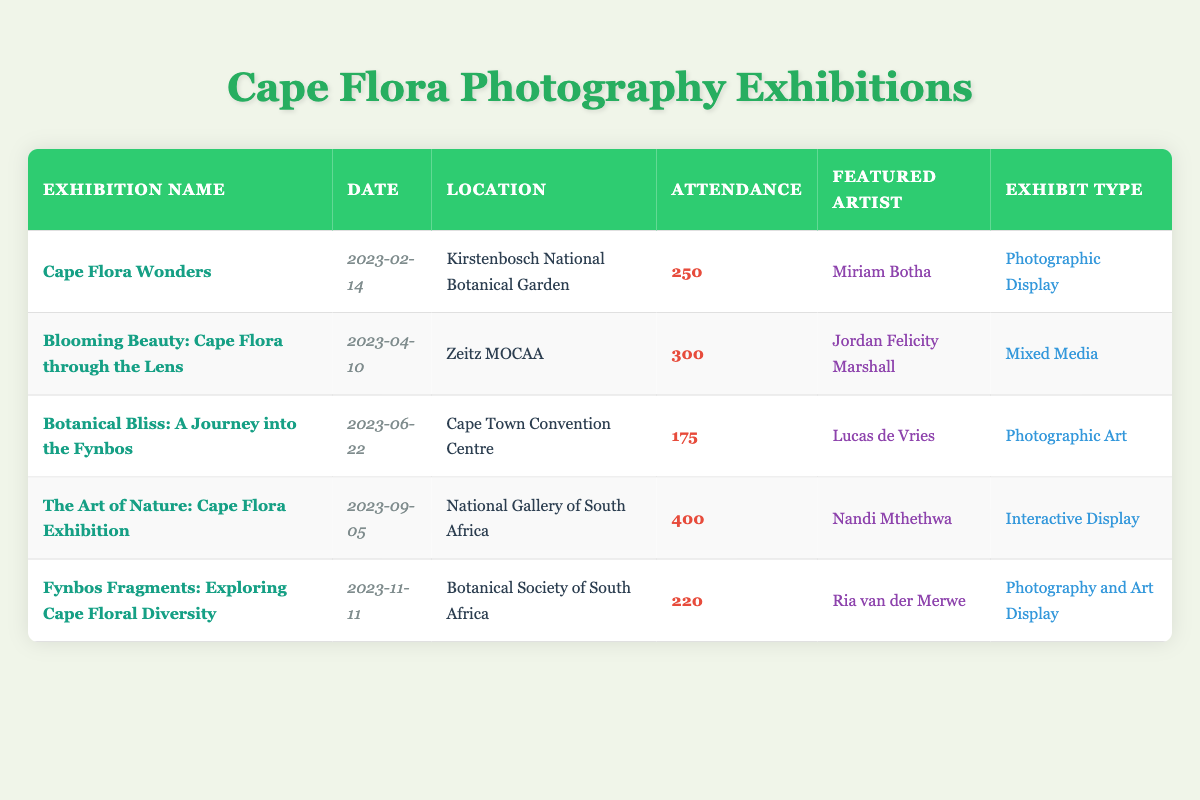What is the total attendance across all exhibitions? To find the total attendance, we sum the attendance for each exhibition: 250 + 300 + 175 + 400 + 220 = 1345.
Answer: 1345 Which exhibition had the highest attendance, and what was the number of attendees? By examining the attendance figures, "The Art of Nature: Cape Flora Exhibition" had the highest attendance at 400.
Answer: The Art of Nature: Cape Flora Exhibition, 400 How many exhibitions were held in the year 2023? There are 5 rows in the table, each representing an exhibition held in 2023.
Answer: 5 Is the exhibit type for "Fynbos Fragments: Exploring Cape Floral Diversity" a Photographic Display? Looking at the table, the exhibit type listed for this exhibition is "Photography and Art Display." Therefore, the statement is false.
Answer: No What is the average attendance for the exhibitions? First, we calculate the total attendance (1345) as found previously. Then, divide it by the number of exhibitions (5): 1345 / 5 = 269.
Answer: 269 Which artist featured at the exhibition held on September 5th, 2023? By checking the date, the exhibition held on September 5th is "The Art of Nature: Cape Flora Exhibition," and the featured artist is Nandi Mthethwa.
Answer: Nandi Mthethwa Did more than half of the exhibitions have an attendance greater than 200? There are 3 exhibitions with attendance above 200: "Blooming Beauty: Cape Flora through the Lens," "The Art of Nature: Cape Flora Exhibition," and "Fynbos Fragments: Exploring Cape Floral Diversity." Since 3 out of 5 is more than half, the answer is yes.
Answer: Yes List the locations of the exhibitions in order of attendance from highest to lowest. The order of exhibitions by attendance is: National Gallery of South Africa, Zeitz MOCAA, Kirstenbosch National Botanical Garden, Botanical Society of South Africa, and Cape Town Convention Centre. The corresponding locations are: National Gallery of South Africa, Zeitz MOCAA, Kirstenbosch National Botanical Garden, Botanical Society of South Africa, and Cape Town Convention Centre.
Answer: National Gallery of South Africa, Zeitz MOCAA, Kirstenbosch National Botanical Garden, Botanical Society of South Africa, Cape Town Convention Centre What is the date of the "Botanical Bliss: A Journey into the Fynbos" exhibition? The corresponding date for this exhibition is listed directly in the table as June 22, 2023.
Answer: June 22, 2023 